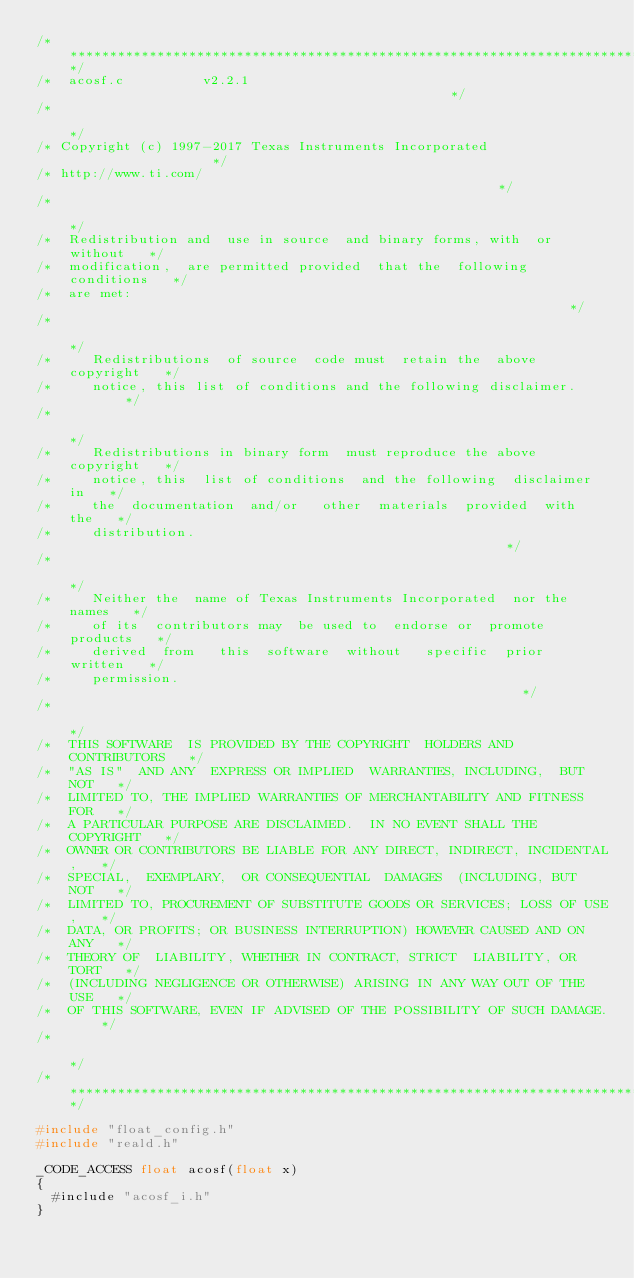Convert code to text. <code><loc_0><loc_0><loc_500><loc_500><_C_>/****************************************************************************/
/*  acosf.c          v2.2.1                                                 */
/*                                                                          */
/* Copyright (c) 1997-2017 Texas Instruments Incorporated                   */
/* http://www.ti.com/                                                       */
/*                                                                          */
/*  Redistribution and  use in source  and binary forms, with  or without   */
/*  modification,  are permitted provided  that the  following conditions   */
/*  are met:                                                                */
/*                                                                          */
/*     Redistributions  of source  code must  retain the  above copyright   */
/*     notice, this list of conditions and the following disclaimer.        */
/*                                                                          */
/*     Redistributions in binary form  must reproduce the above copyright   */
/*     notice, this  list of conditions  and the following  disclaimer in   */
/*     the  documentation  and/or   other  materials  provided  with  the   */
/*     distribution.                                                        */
/*                                                                          */
/*     Neither the  name of Texas Instruments Incorporated  nor the names   */
/*     of its  contributors may  be used to  endorse or  promote products   */
/*     derived  from   this  software  without   specific  prior  written   */
/*     permission.                                                          */
/*                                                                          */
/*  THIS SOFTWARE  IS PROVIDED BY THE COPYRIGHT  HOLDERS AND CONTRIBUTORS   */
/*  "AS IS"  AND ANY  EXPRESS OR IMPLIED  WARRANTIES, INCLUDING,  BUT NOT   */
/*  LIMITED TO, THE IMPLIED WARRANTIES OF MERCHANTABILITY AND FITNESS FOR   */
/*  A PARTICULAR PURPOSE ARE DISCLAIMED.  IN NO EVENT SHALL THE COPYRIGHT   */
/*  OWNER OR CONTRIBUTORS BE LIABLE FOR ANY DIRECT, INDIRECT, INCIDENTAL,   */
/*  SPECIAL,  EXEMPLARY,  OR CONSEQUENTIAL  DAMAGES  (INCLUDING, BUT  NOT   */
/*  LIMITED TO, PROCUREMENT OF SUBSTITUTE GOODS OR SERVICES; LOSS OF USE,   */
/*  DATA, OR PROFITS; OR BUSINESS INTERRUPTION) HOWEVER CAUSED AND ON ANY   */
/*  THEORY OF  LIABILITY, WHETHER IN CONTRACT, STRICT  LIABILITY, OR TORT   */
/*  (INCLUDING NEGLIGENCE OR OTHERWISE) ARISING IN ANY WAY OUT OF THE USE   */
/*  OF THIS SOFTWARE, EVEN IF ADVISED OF THE POSSIBILITY OF SUCH DAMAGE.    */
/*                                                                          */
/****************************************************************************/

#include "float_config.h"
#include "reald.h"

_CODE_ACCESS float acosf(float x)
{
  #include "acosf_i.h"
}

</code> 